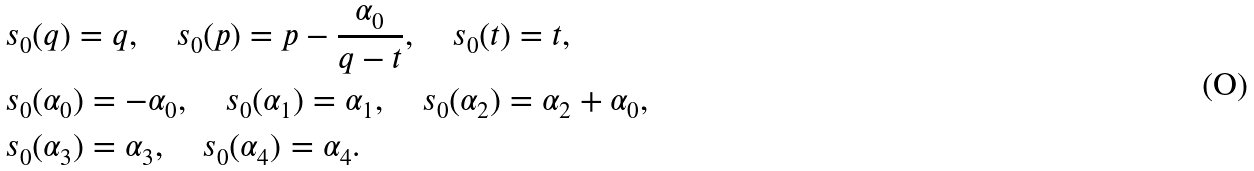Convert formula to latex. <formula><loc_0><loc_0><loc_500><loc_500>& s _ { 0 } ( q ) = q , \quad s _ { 0 } ( p ) = p - \frac { \alpha _ { 0 } } { q - t } , \quad s _ { 0 } ( t ) = t , \\ & s _ { 0 } ( \alpha _ { 0 } ) = - \alpha _ { 0 } , \quad s _ { 0 } ( \alpha _ { 1 } ) = \alpha _ { 1 } , \quad s _ { 0 } ( \alpha _ { 2 } ) = \alpha _ { 2 } + \alpha _ { 0 } , \\ & s _ { 0 } ( \alpha _ { 3 } ) = \alpha _ { 3 } , \quad s _ { 0 } ( \alpha _ { 4 } ) = \alpha _ { 4 } .</formula> 